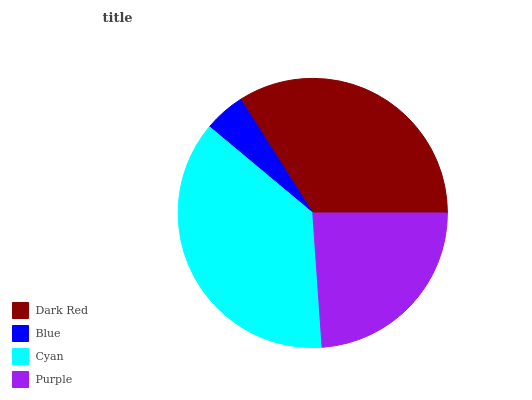Is Blue the minimum?
Answer yes or no. Yes. Is Cyan the maximum?
Answer yes or no. Yes. Is Cyan the minimum?
Answer yes or no. No. Is Blue the maximum?
Answer yes or no. No. Is Cyan greater than Blue?
Answer yes or no. Yes. Is Blue less than Cyan?
Answer yes or no. Yes. Is Blue greater than Cyan?
Answer yes or no. No. Is Cyan less than Blue?
Answer yes or no. No. Is Dark Red the high median?
Answer yes or no. Yes. Is Purple the low median?
Answer yes or no. Yes. Is Purple the high median?
Answer yes or no. No. Is Dark Red the low median?
Answer yes or no. No. 